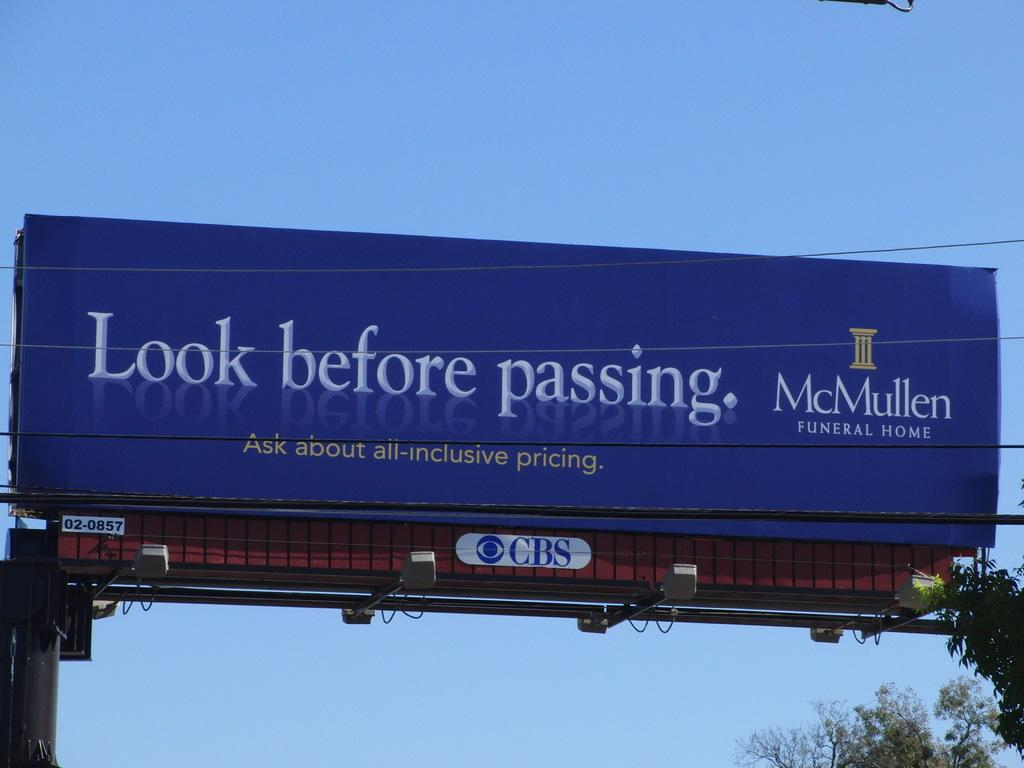<image>
Present a compact description of the photo's key features. A roadside billboard displays an ad for a funeral home. 